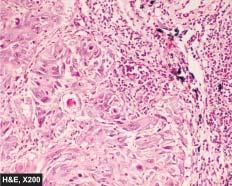re iseases evident?
Answer the question using a single word or phrase. No 